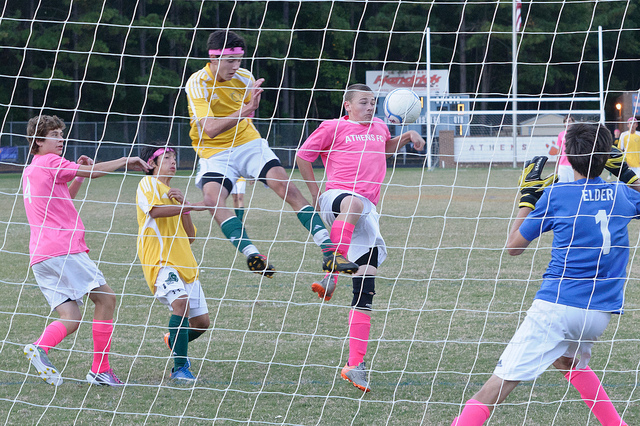Identify and read out the text in this image. ATHERS ELDER 1 